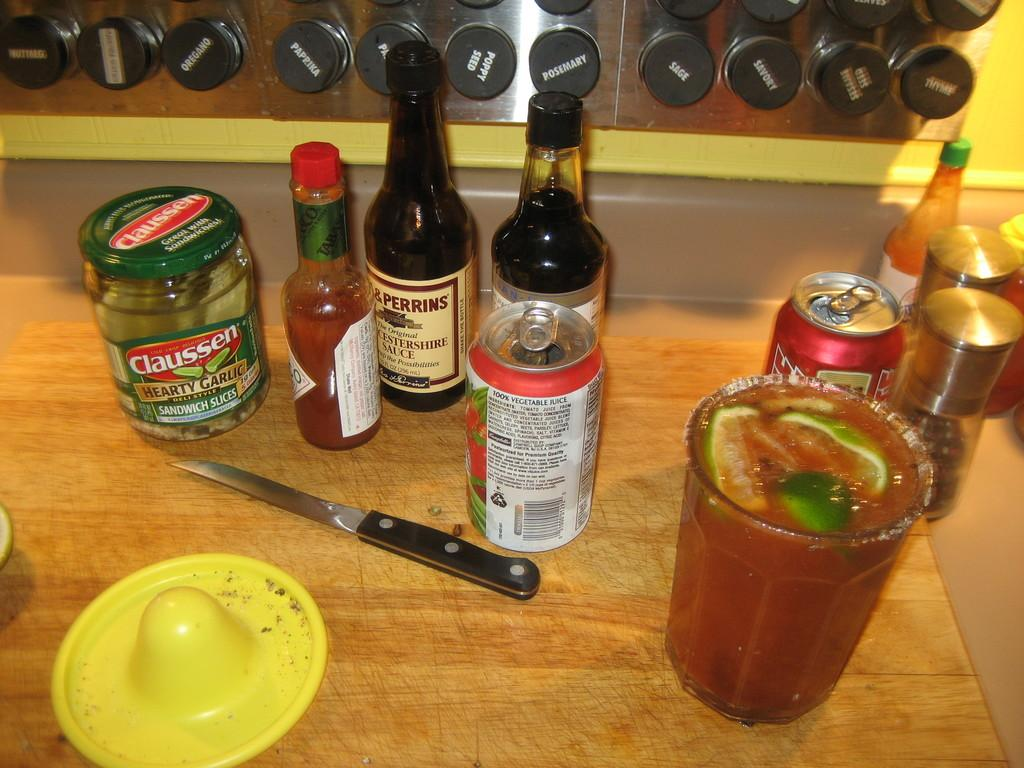<image>
Write a terse but informative summary of the picture. a jar of claussen hearty garlic dely style sandwich slices on a counter 